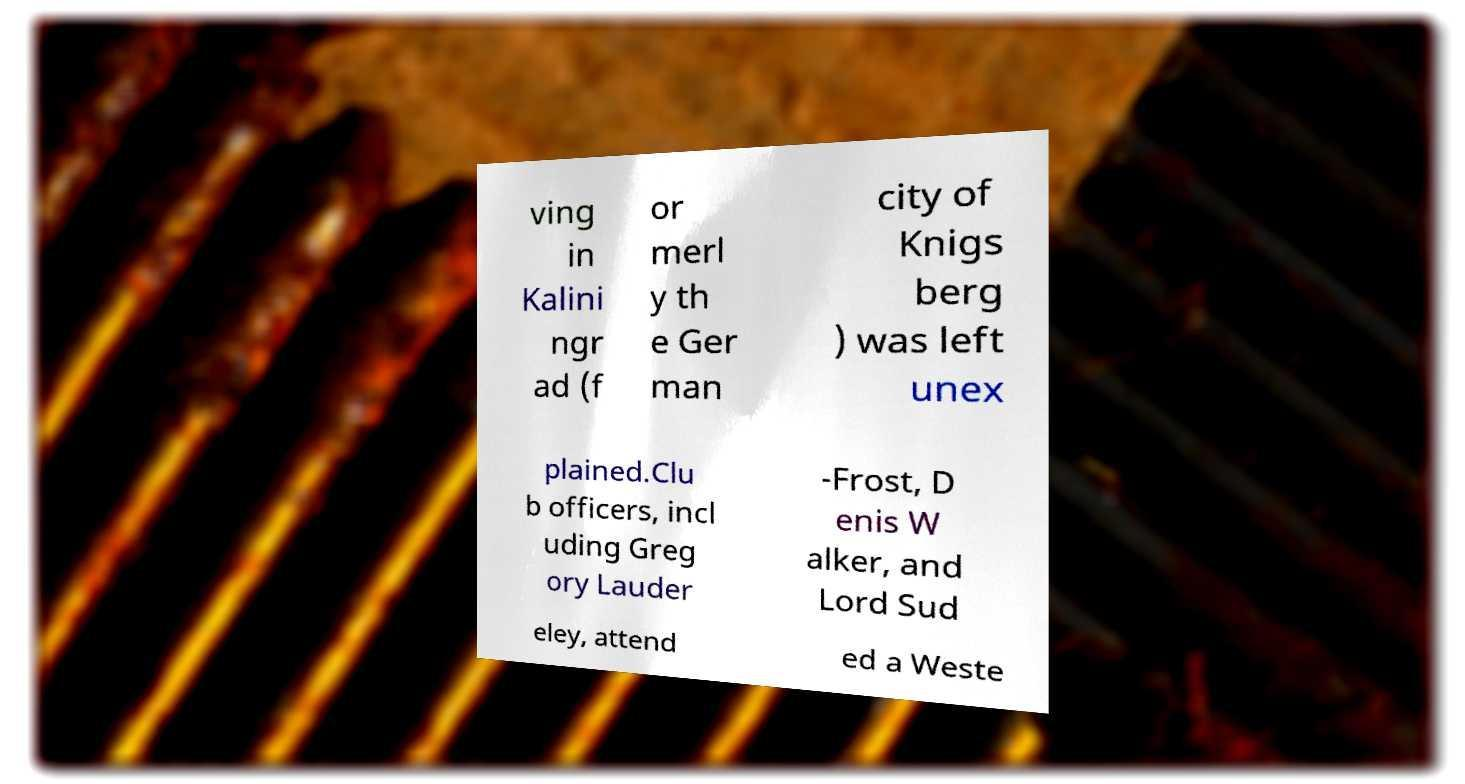I need the written content from this picture converted into text. Can you do that? ving in Kalini ngr ad (f or merl y th e Ger man city of Knigs berg ) was left unex plained.Clu b officers, incl uding Greg ory Lauder -Frost, D enis W alker, and Lord Sud eley, attend ed a Weste 